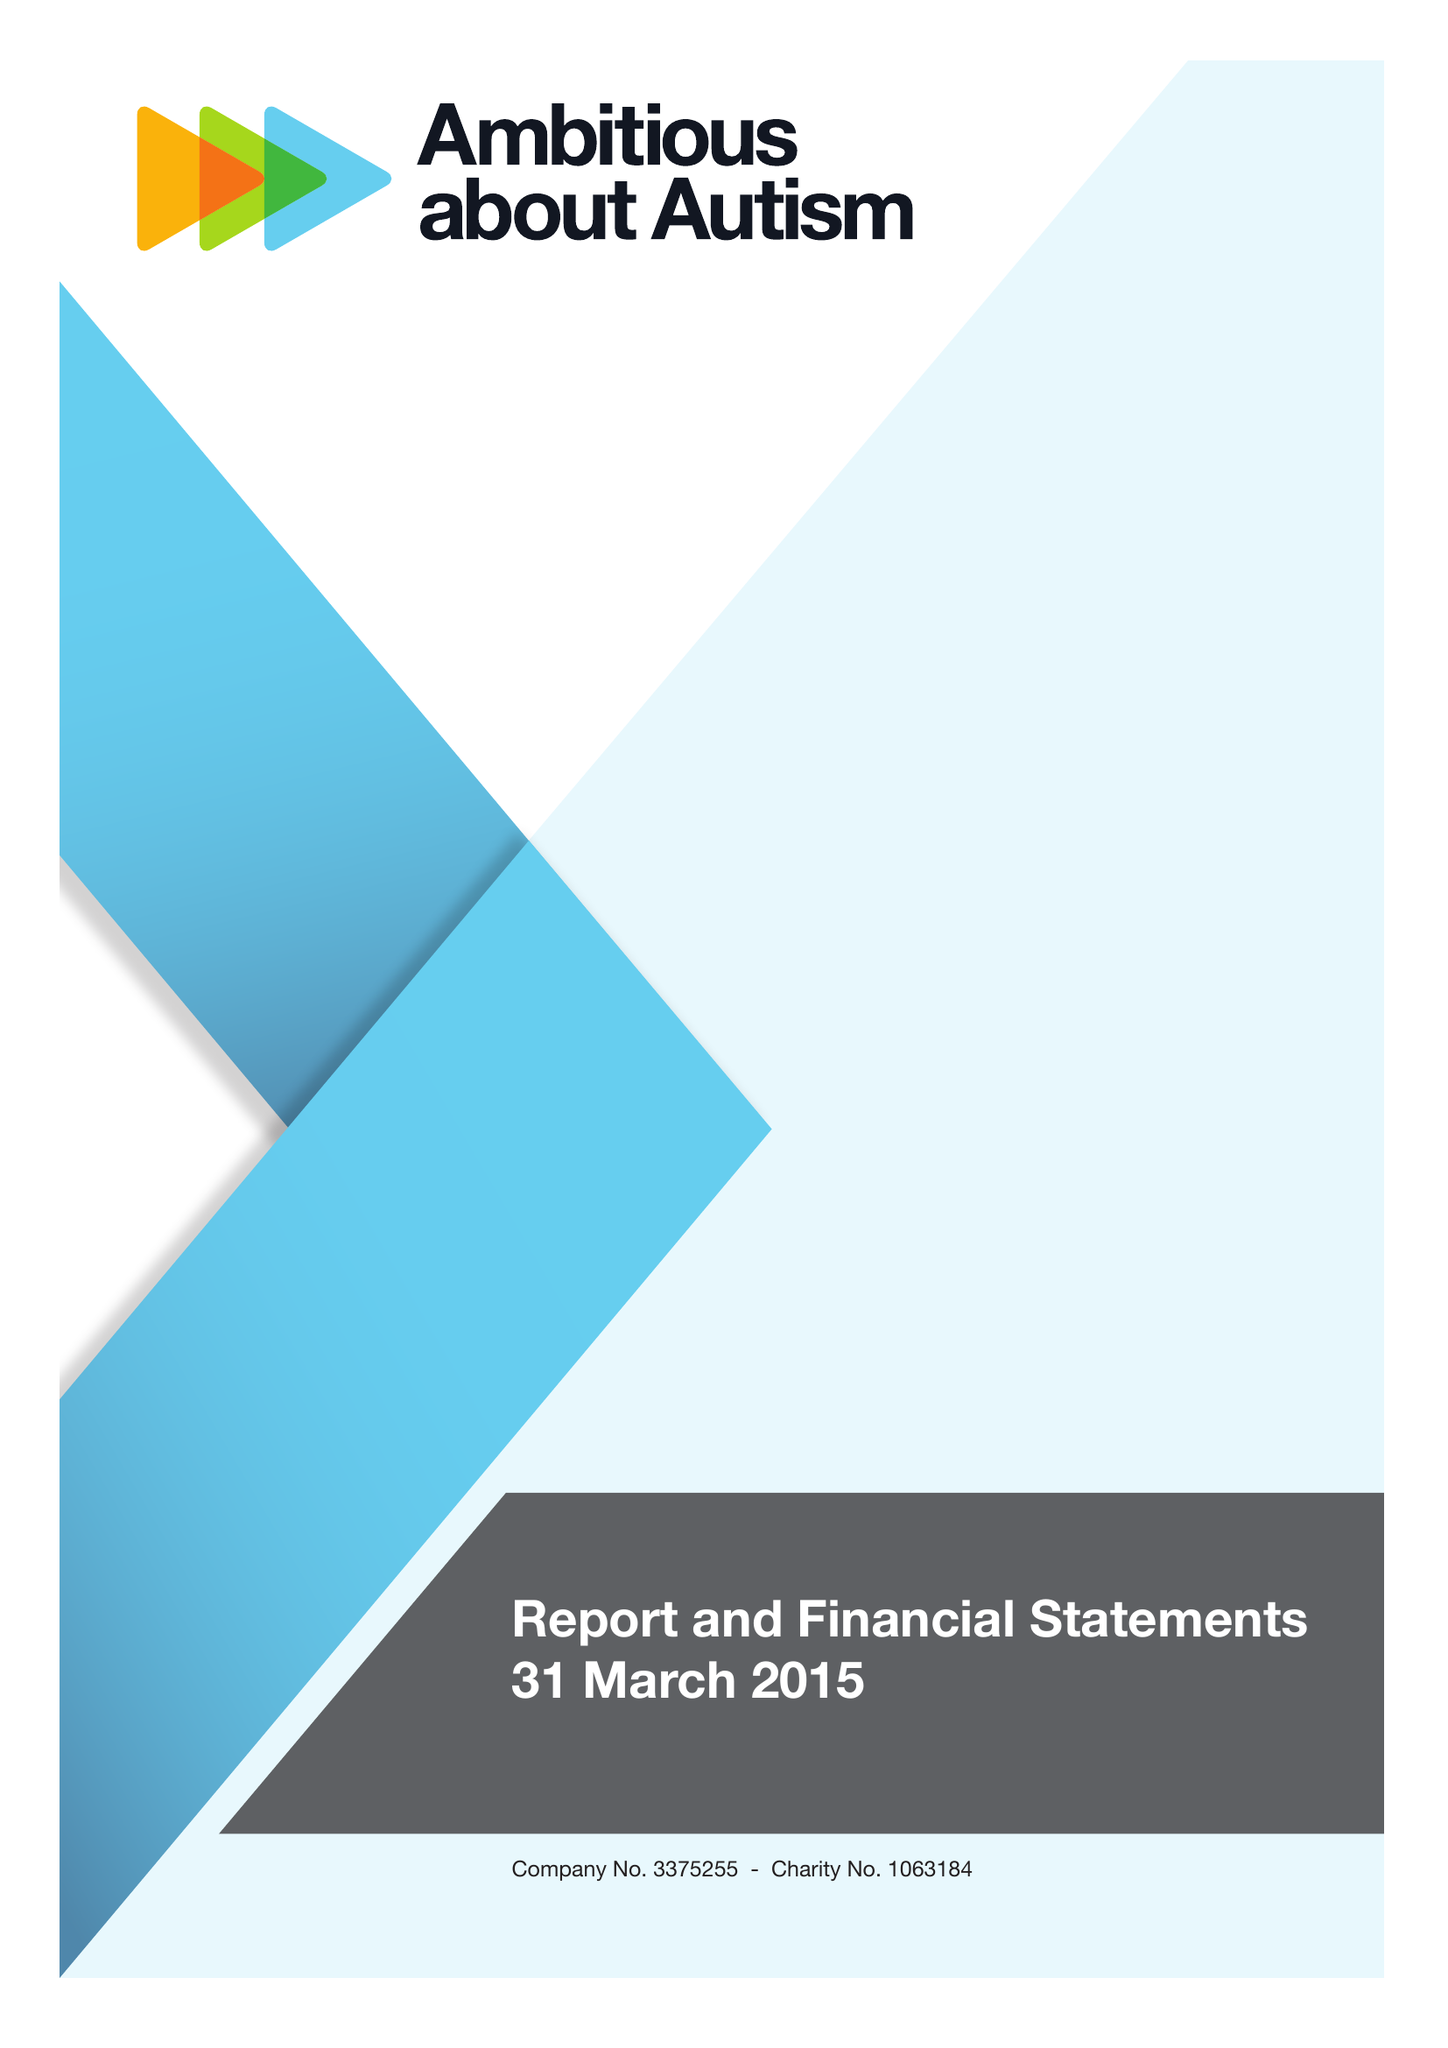What is the value for the charity_number?
Answer the question using a single word or phrase. 1063184 